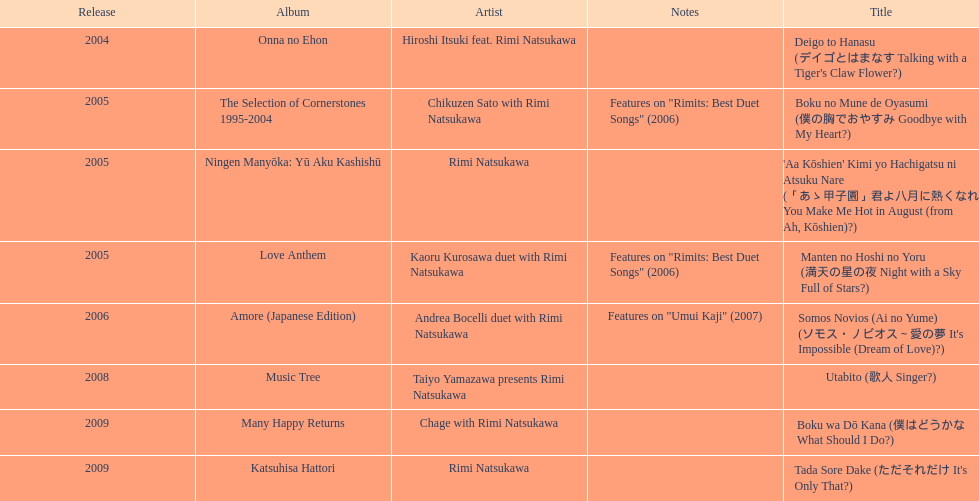Which year had the most titles released? 2005. 